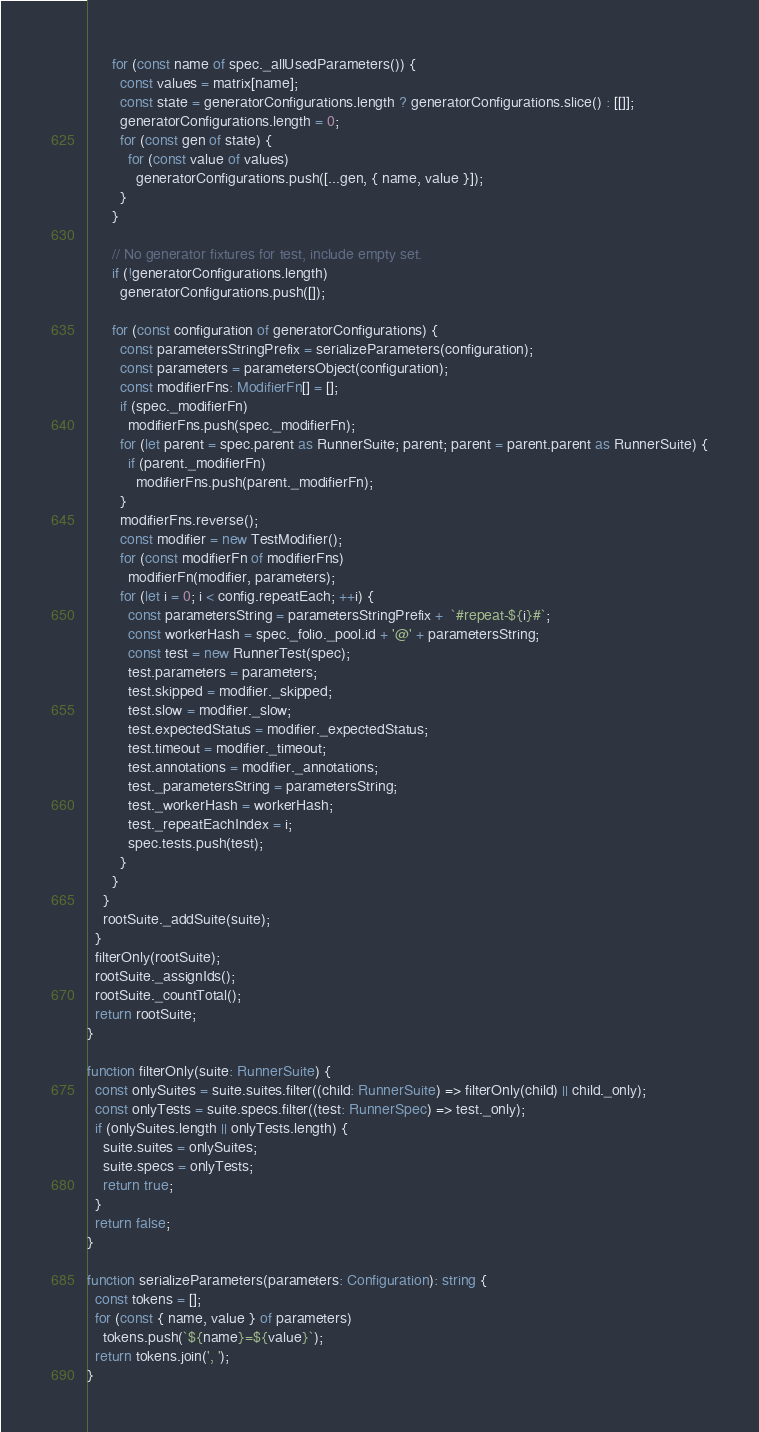<code> <loc_0><loc_0><loc_500><loc_500><_TypeScript_>      for (const name of spec._allUsedParameters()) {
        const values = matrix[name];
        const state = generatorConfigurations.length ? generatorConfigurations.slice() : [[]];
        generatorConfigurations.length = 0;
        for (const gen of state) {
          for (const value of values)
            generatorConfigurations.push([...gen, { name, value }]);
        }
      }

      // No generator fixtures for test, include empty set.
      if (!generatorConfigurations.length)
        generatorConfigurations.push([]);

      for (const configuration of generatorConfigurations) {
        const parametersStringPrefix = serializeParameters(configuration);
        const parameters = parametersObject(configuration);
        const modifierFns: ModifierFn[] = [];
        if (spec._modifierFn)
          modifierFns.push(spec._modifierFn);
        for (let parent = spec.parent as RunnerSuite; parent; parent = parent.parent as RunnerSuite) {
          if (parent._modifierFn)
            modifierFns.push(parent._modifierFn);
        }
        modifierFns.reverse();
        const modifier = new TestModifier();
        for (const modifierFn of modifierFns)
          modifierFn(modifier, parameters);
        for (let i = 0; i < config.repeatEach; ++i) {
          const parametersString = parametersStringPrefix +  `#repeat-${i}#`;
          const workerHash = spec._folio._pool.id + '@' + parametersString;
          const test = new RunnerTest(spec);
          test.parameters = parameters;
          test.skipped = modifier._skipped;
          test.slow = modifier._slow;
          test.expectedStatus = modifier._expectedStatus;
          test.timeout = modifier._timeout;
          test.annotations = modifier._annotations;
          test._parametersString = parametersString;
          test._workerHash = workerHash;
          test._repeatEachIndex = i;
          spec.tests.push(test);
        }
      }
    }
    rootSuite._addSuite(suite);
  }
  filterOnly(rootSuite);
  rootSuite._assignIds();
  rootSuite._countTotal();
  return rootSuite;
}

function filterOnly(suite: RunnerSuite) {
  const onlySuites = suite.suites.filter((child: RunnerSuite) => filterOnly(child) || child._only);
  const onlyTests = suite.specs.filter((test: RunnerSpec) => test._only);
  if (onlySuites.length || onlyTests.length) {
    suite.suites = onlySuites;
    suite.specs = onlyTests;
    return true;
  }
  return false;
}

function serializeParameters(parameters: Configuration): string {
  const tokens = [];
  for (const { name, value } of parameters)
    tokens.push(`${name}=${value}`);
  return tokens.join(', ');
}
</code> 